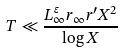Convert formula to latex. <formula><loc_0><loc_0><loc_500><loc_500>T \ll \frac { L _ { \infty } ^ { \varepsilon } r _ { \infty } r ^ { \prime } X ^ { 2 } } { \log X }</formula> 